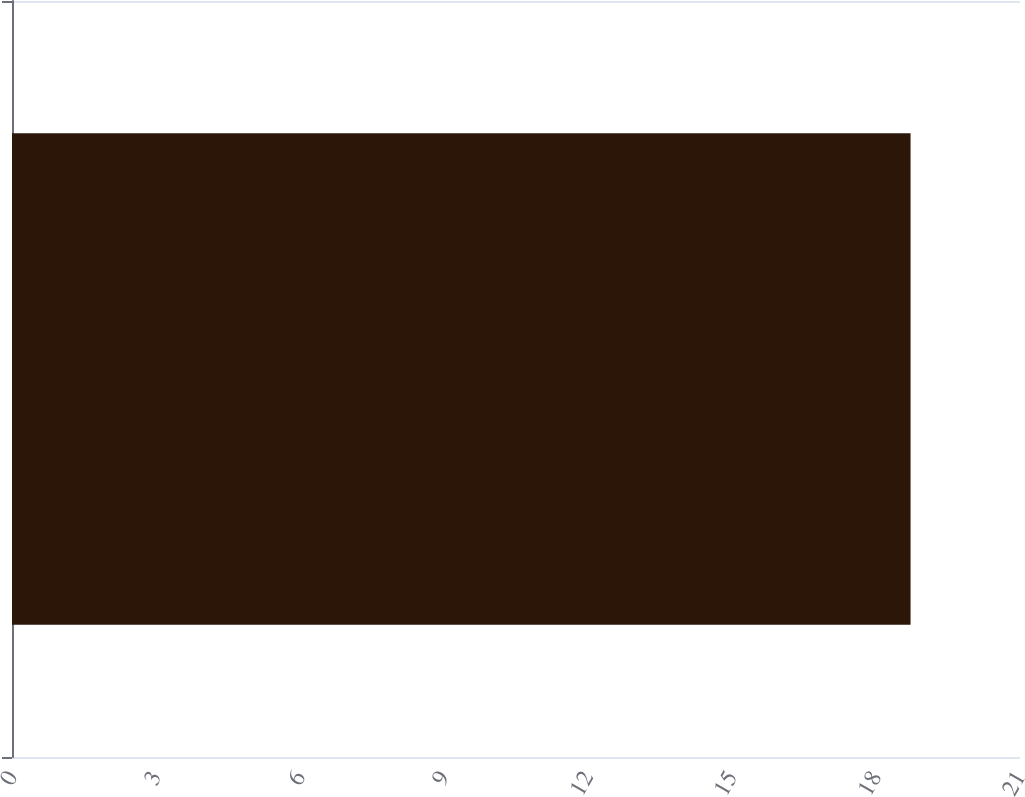<chart> <loc_0><loc_0><loc_500><loc_500><bar_chart><ecel><nl><fcel>18.72<nl></chart> 